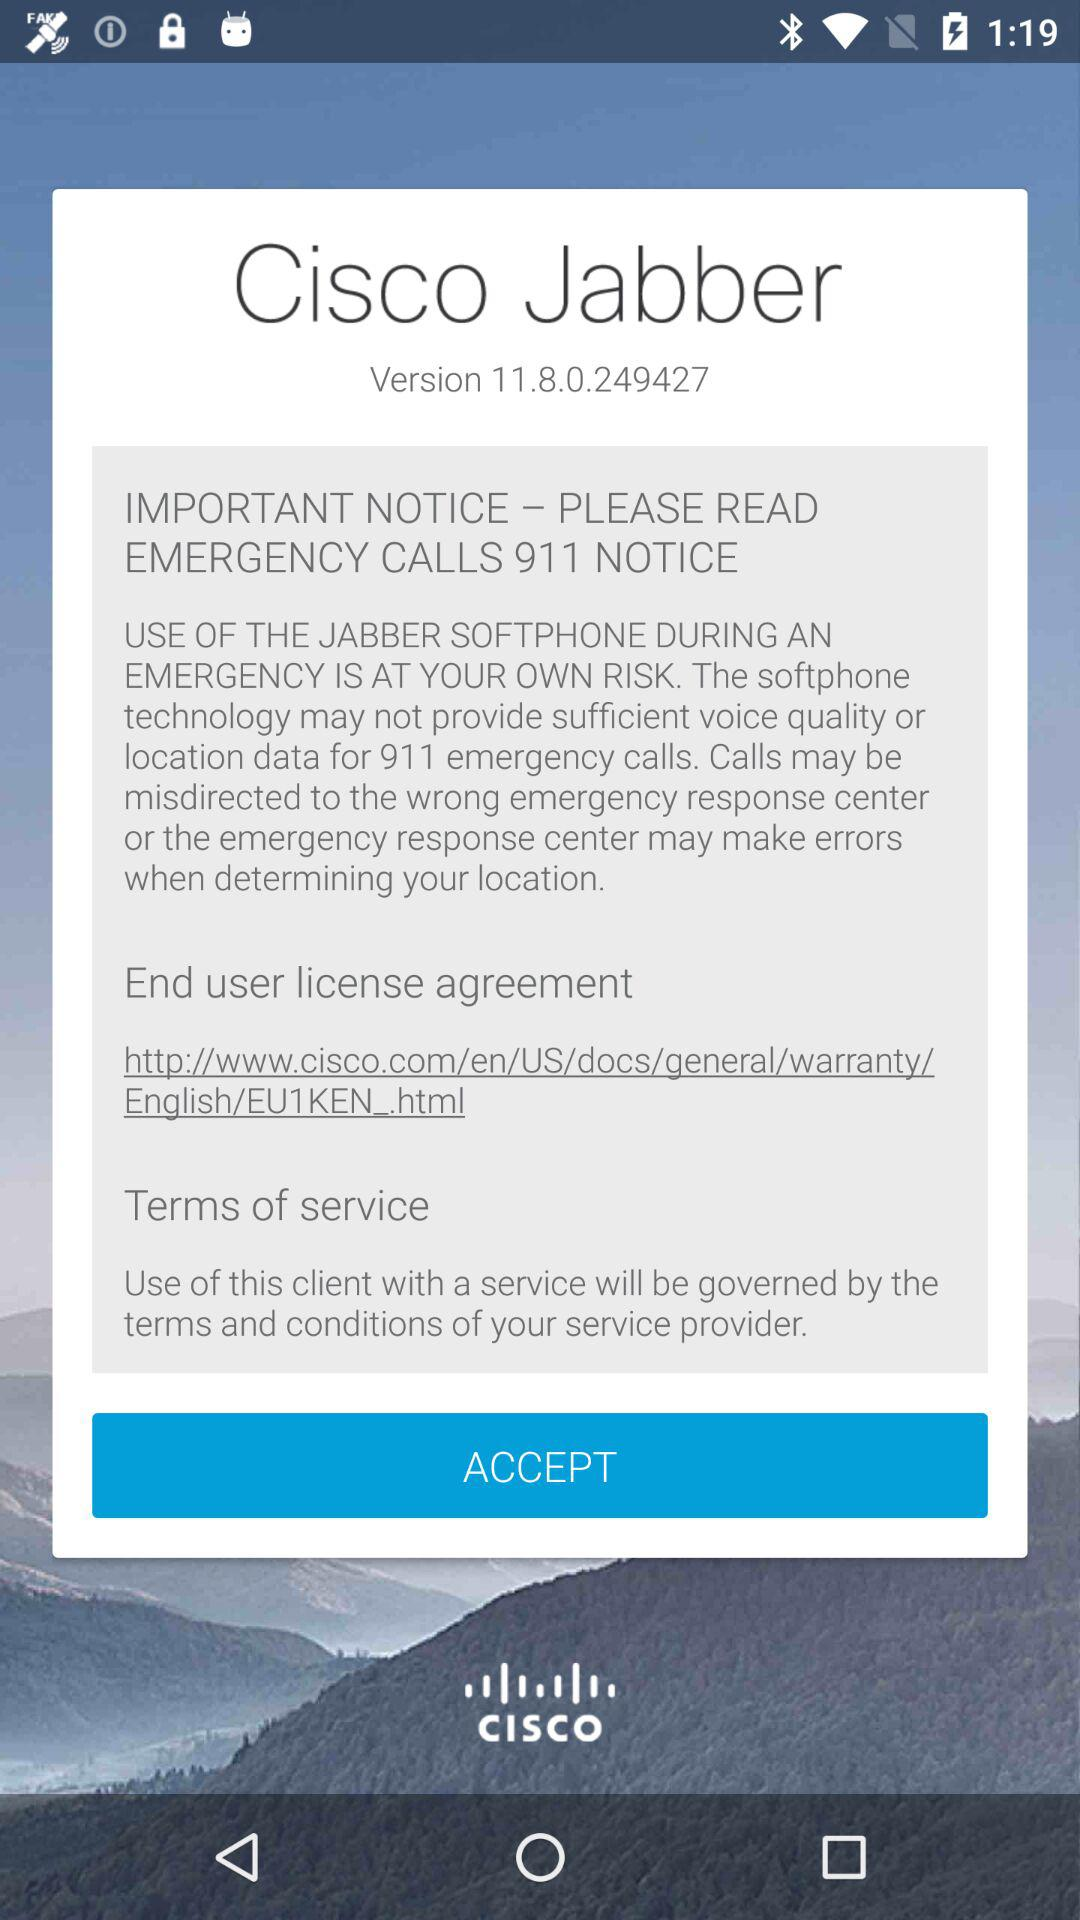Which is the version? The version is 11.8.0.249427. 